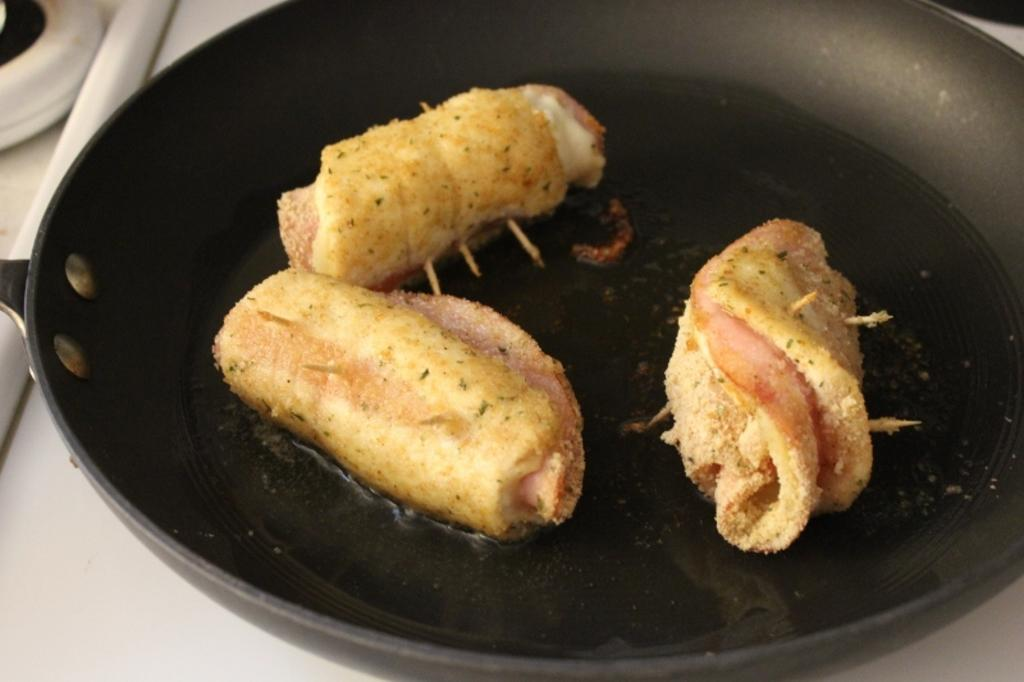What type of appliance is present in the image? There is a stove in the image. What is placed on top of the stove? There is a pan on the stove. What is inside the pan? There is a food item in the pan. What type of fish can be seen on the scale in the image? There is no fish or scale present in the image. 